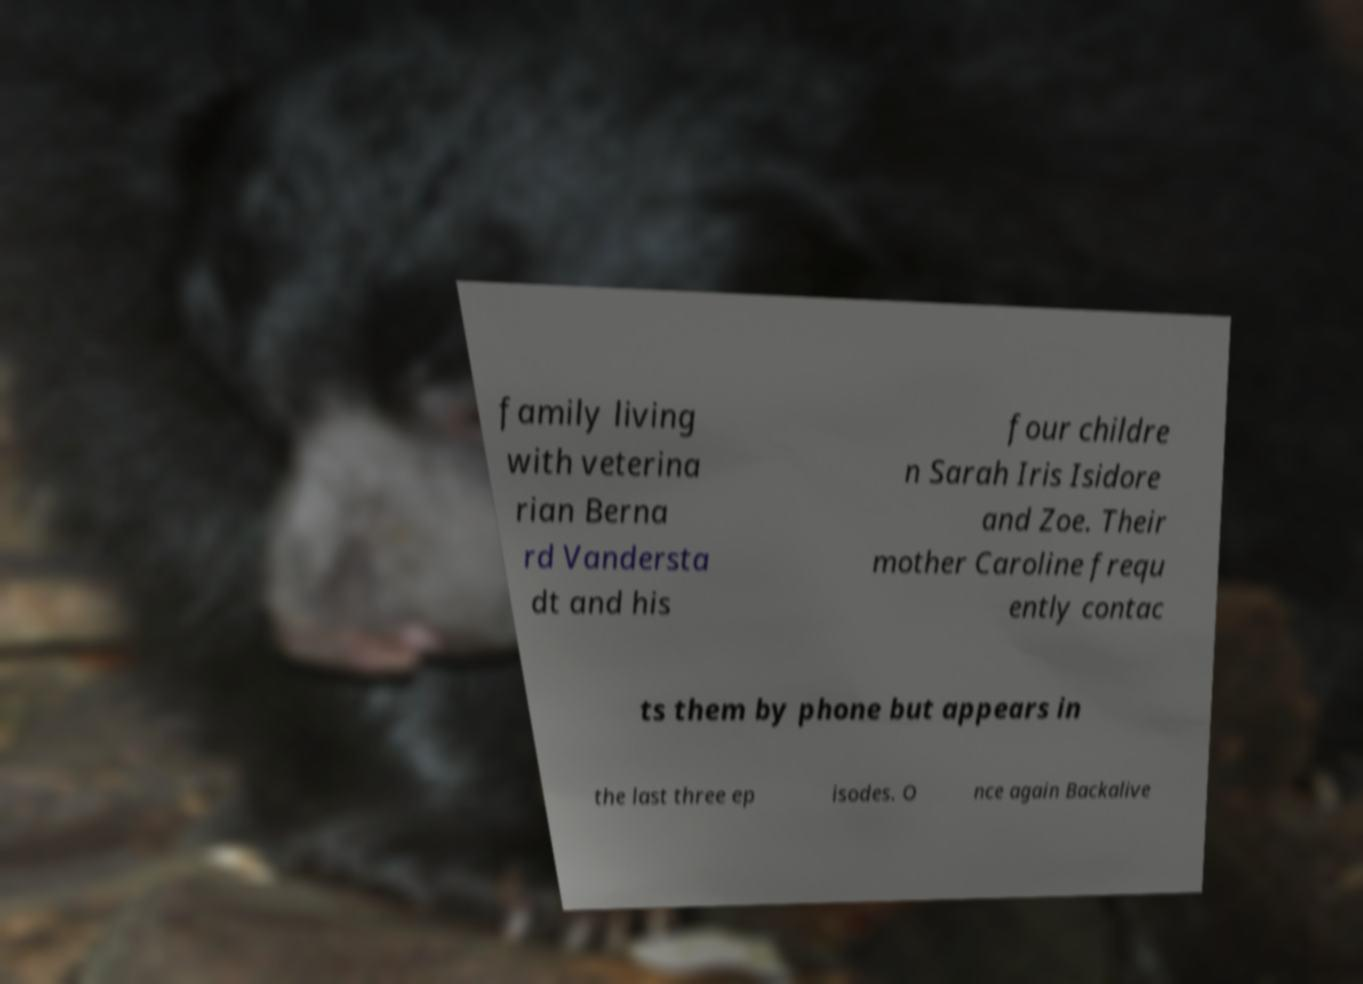Can you accurately transcribe the text from the provided image for me? family living with veterina rian Berna rd Vandersta dt and his four childre n Sarah Iris Isidore and Zoe. Their mother Caroline frequ ently contac ts them by phone but appears in the last three ep isodes. O nce again Backalive 